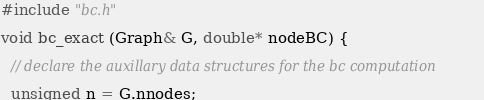Convert code to text. <code><loc_0><loc_0><loc_500><loc_500><_Cuda_>#include "bc.h"

void bc_exact (Graph& G, double* nodeBC) {
  
  // declare the auxillary data structures for the bc computation
  
  unsigned n = G.nnodes;</code> 